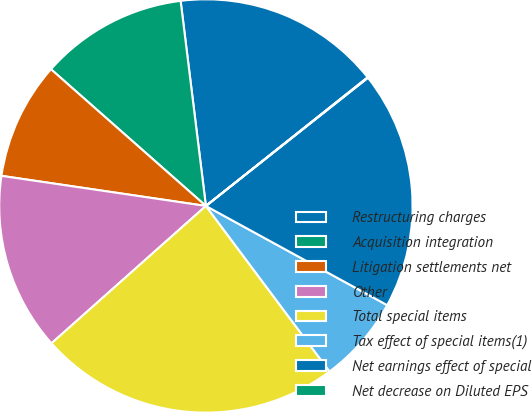<chart> <loc_0><loc_0><loc_500><loc_500><pie_chart><fcel>Restructuring charges<fcel>Acquisition integration<fcel>Litigation settlements net<fcel>Other<fcel>Total special items<fcel>Tax effect of special items(1)<fcel>Net earnings effect of special<fcel>Net decrease on Diluted EPS<nl><fcel>16.26%<fcel>11.54%<fcel>9.18%<fcel>13.9%<fcel>23.64%<fcel>6.82%<fcel>18.62%<fcel>0.04%<nl></chart> 